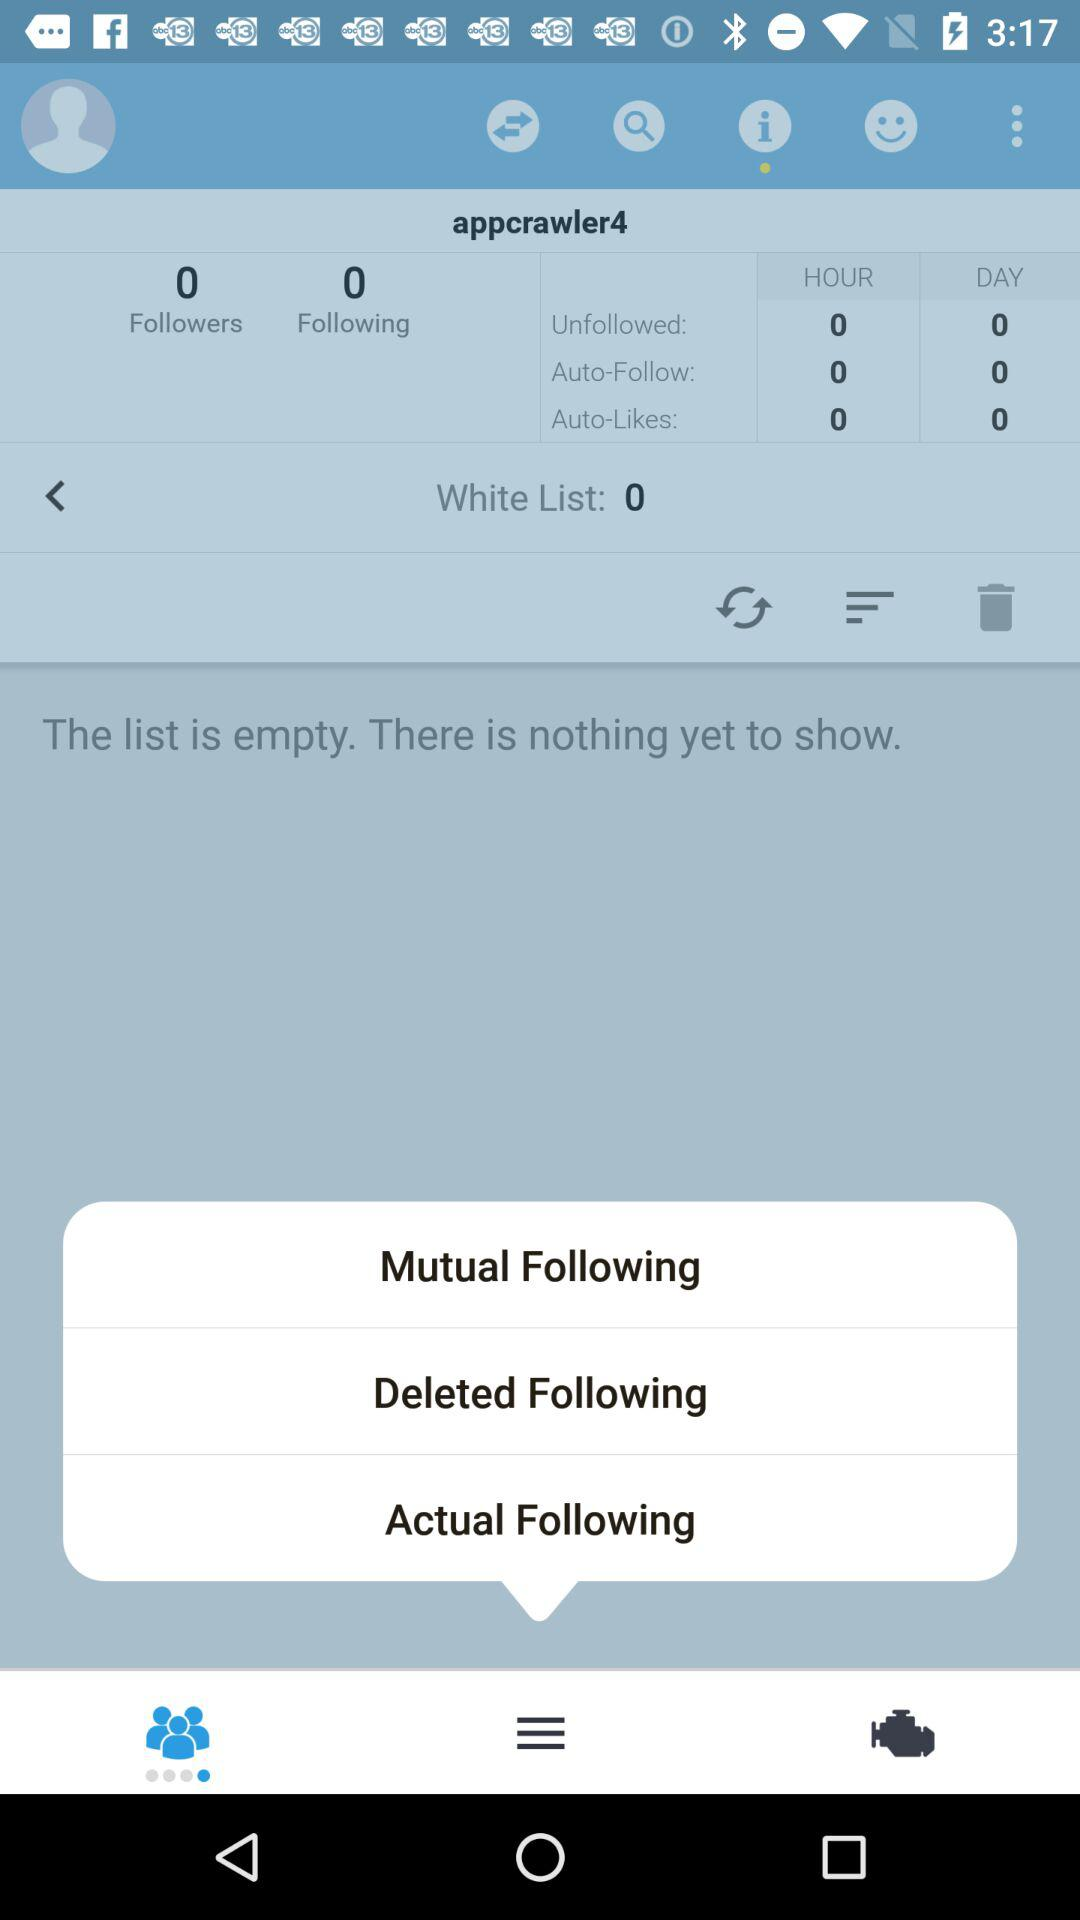How many people are followed by a user? There are 0 people followed by the user. 